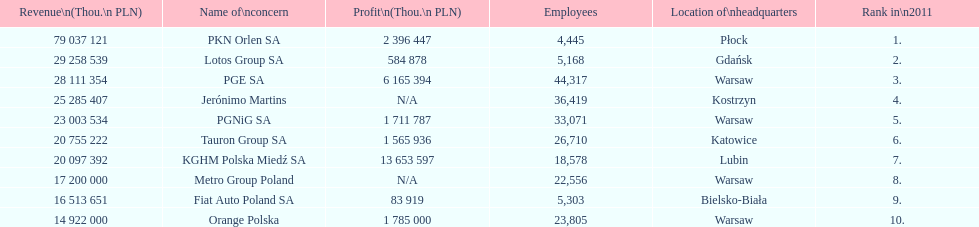Can you parse all the data within this table? {'header': ['Revenue\\n(Thou.\\n\xa0PLN)', 'Name of\\nconcern', 'Profit\\n(Thou.\\n\xa0PLN)', 'Employees', 'Location of\\nheadquarters', 'Rank in\\n2011'], 'rows': [['79 037 121', 'PKN Orlen SA', '2 396 447', '4,445', 'Płock', '1.'], ['29 258 539', 'Lotos Group SA', '584 878', '5,168', 'Gdańsk', '2.'], ['28 111 354', 'PGE SA', '6 165 394', '44,317', 'Warsaw', '3.'], ['25 285 407', 'Jerónimo Martins', 'N/A', '36,419', 'Kostrzyn', '4.'], ['23 003 534', 'PGNiG SA', '1 711 787', '33,071', 'Warsaw', '5.'], ['20 755 222', 'Tauron Group SA', '1 565 936', '26,710', 'Katowice', '6.'], ['20 097 392', 'KGHM Polska Miedź SA', '13 653 597', '18,578', 'Lubin', '7.'], ['17 200 000', 'Metro Group Poland', 'N/A', '22,556', 'Warsaw', '8.'], ['16 513 651', 'Fiat Auto Poland SA', '83 919', '5,303', 'Bielsko-Biała', '9.'], ['14 922 000', 'Orange Polska', '1 785 000', '23,805', 'Warsaw', '10.']]} What company has the top number of employees? PGE SA. 